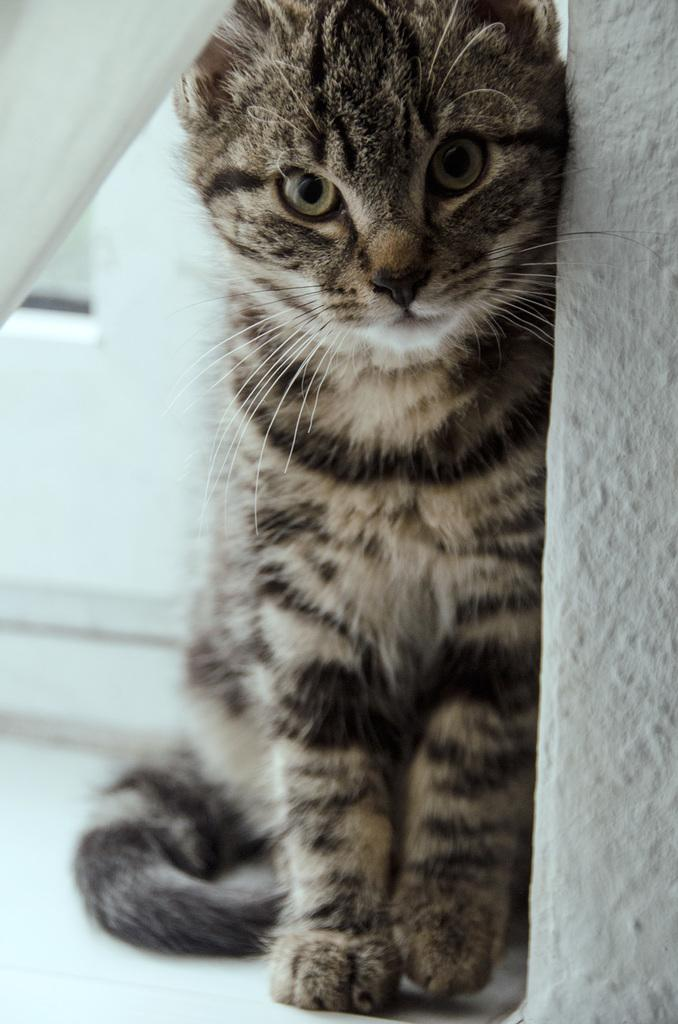What is the main background element in the image? There is a white wall in the image. What type of animal is present in the image? There is a cat in the image. Can you describe the appearance of the cat? The cat has a white and black color pattern. Is there any visible wound on the cat in the image? There is no mention of a wound on the cat in the image, and therefore it cannot be determined from the provided facts. 